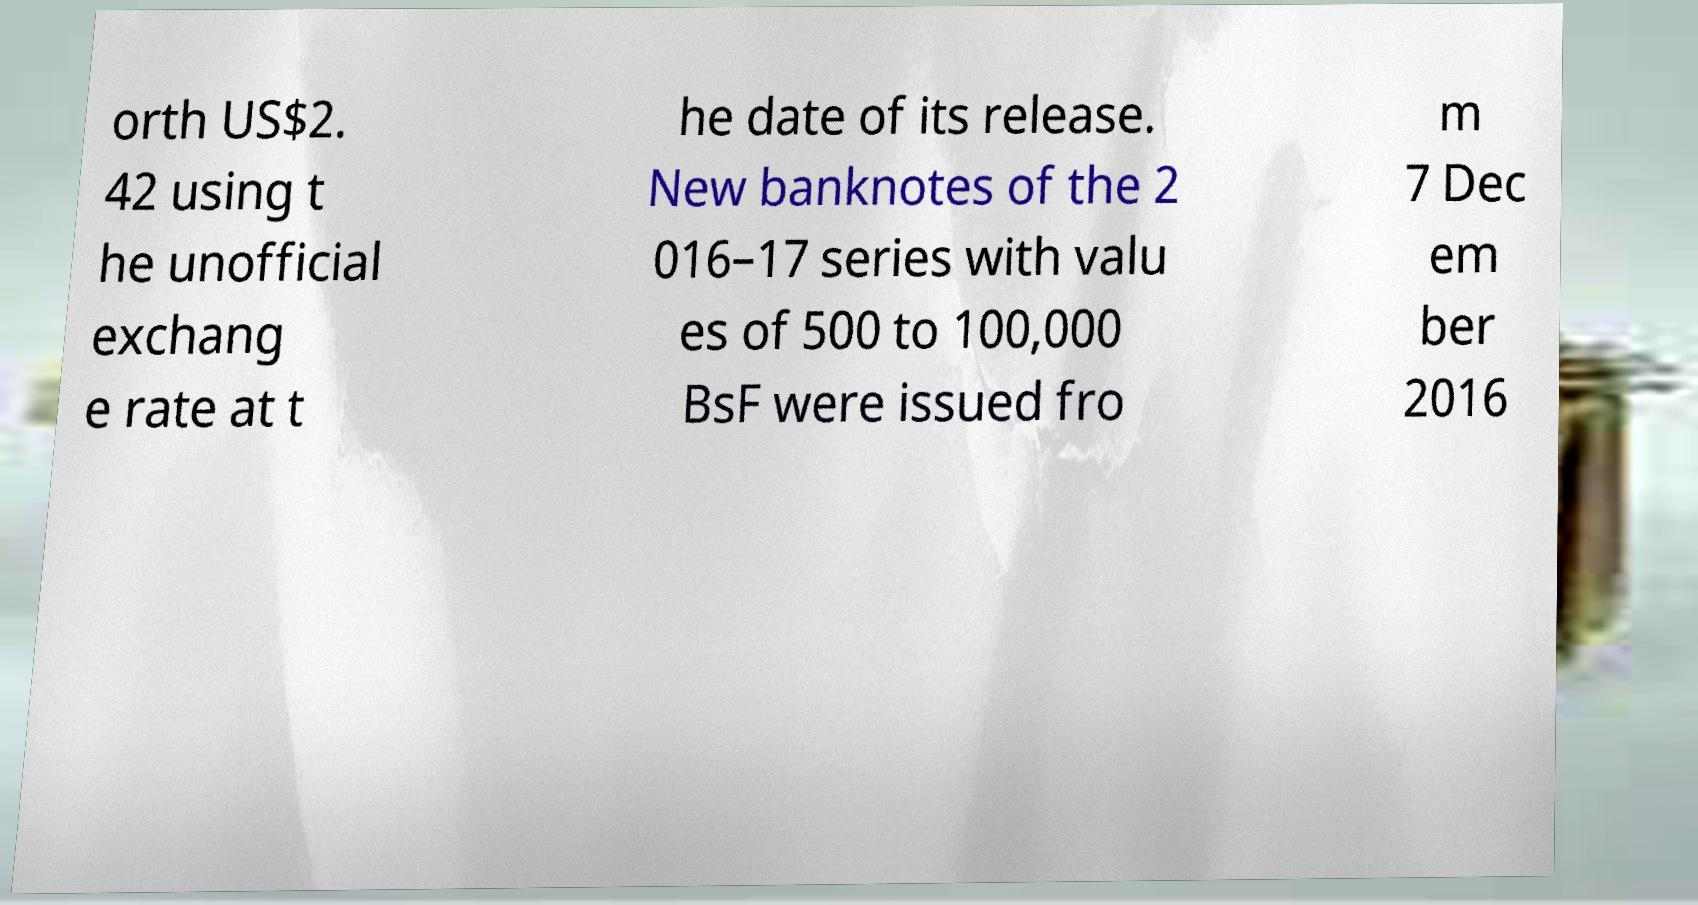I need the written content from this picture converted into text. Can you do that? orth US$2. 42 using t he unofficial exchang e rate at t he date of its release. New banknotes of the 2 016–17 series with valu es of 500 to 100,000 BsF were issued fro m 7 Dec em ber 2016 